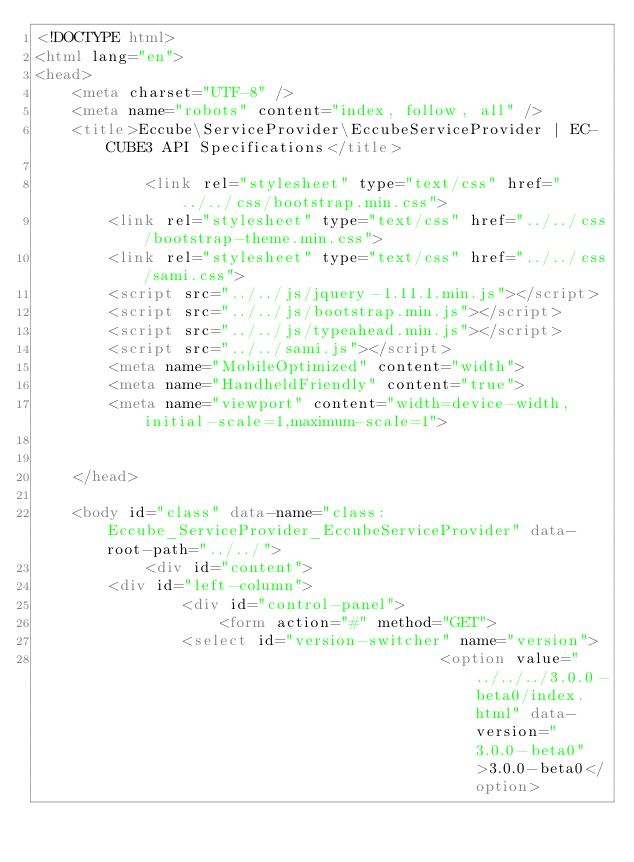Convert code to text. <code><loc_0><loc_0><loc_500><loc_500><_HTML_><!DOCTYPE html>
<html lang="en">
<head>
    <meta charset="UTF-8" />
    <meta name="robots" content="index, follow, all" />
    <title>Eccube\ServiceProvider\EccubeServiceProvider | EC-CUBE3 API Specifications</title>

            <link rel="stylesheet" type="text/css" href="../../css/bootstrap.min.css">
        <link rel="stylesheet" type="text/css" href="../../css/bootstrap-theme.min.css">
        <link rel="stylesheet" type="text/css" href="../../css/sami.css">
        <script src="../../js/jquery-1.11.1.min.js"></script>
        <script src="../../js/bootstrap.min.js"></script>
        <script src="../../js/typeahead.min.js"></script>
        <script src="../../sami.js"></script>
        <meta name="MobileOptimized" content="width">
        <meta name="HandheldFriendly" content="true">
        <meta name="viewport" content="width=device-width,initial-scale=1,maximum-scale=1">
    
    
    </head>

    <body id="class" data-name="class:Eccube_ServiceProvider_EccubeServiceProvider" data-root-path="../../">
            <div id="content">
        <div id="left-column">
                <div id="control-panel">
                    <form action="#" method="GET">
                <select id="version-switcher" name="version">
                                            <option value="../../../3.0.0-beta0/index.html" data-version="3.0.0-beta0">3.0.0-beta0</option></code> 